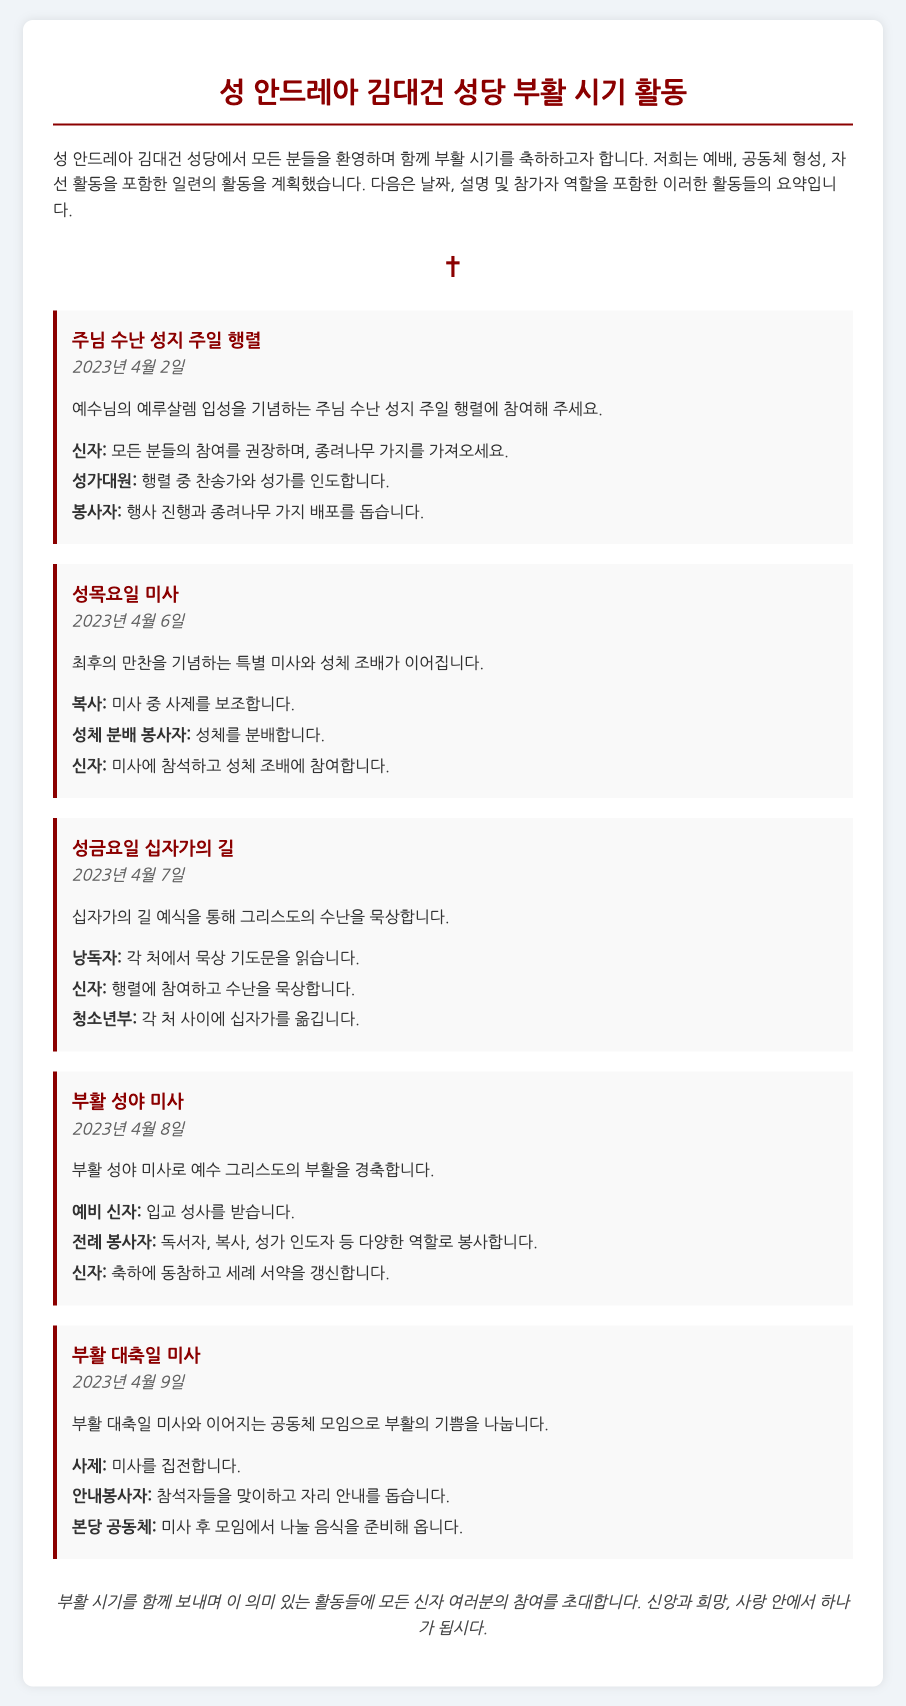what is the title of the document? The title of the document is the main heading at the top, which summarizes the content regarding parish activities.
Answer: 성 안드레아 김대건 성당 부활 시기 활동 what is the date of the 부활 성야 미사? The date is specified in the section describing the event, indicating when this particular mass will occur.
Answer: 2023년 4월 8일 who participates as a 낭독자 during 성금요일 십자가의 길? The participant role of '낭독자' is listed under the roles in the respective event description, showing their responsibility.
Answer: 각 처에서 묵상 기도문을 읽습니다 how many events are included in the document? The number of events is counted based on the individual sections detailing each activity in the document.
Answer: 5 what is the role of the 사제 during 부활 대축일 미사? The role of the 사제 is clearly defined in the event's roles, indicating their specific responsibility during the mass.
Answer: 미사를 집전합니다 what are the participants encouraged to bring for 주님 수난 성지 주일 행렬? The document specifies what participants should bring along for this event to enhance the celebration.
Answer: 종려나무 가지 when is the 성목요일 미사 held? The date for this special mass is mentioned, providing clarity on when the activity takes place during the Easter season.
Answer: 2023년 4월 6일 what is the primary focus of the 부활 대축일 미사? The document summarizes the key aspect of this event, outlining its main purpose for the participants.
Answer: 부활의 기쁨을 나눕니다 